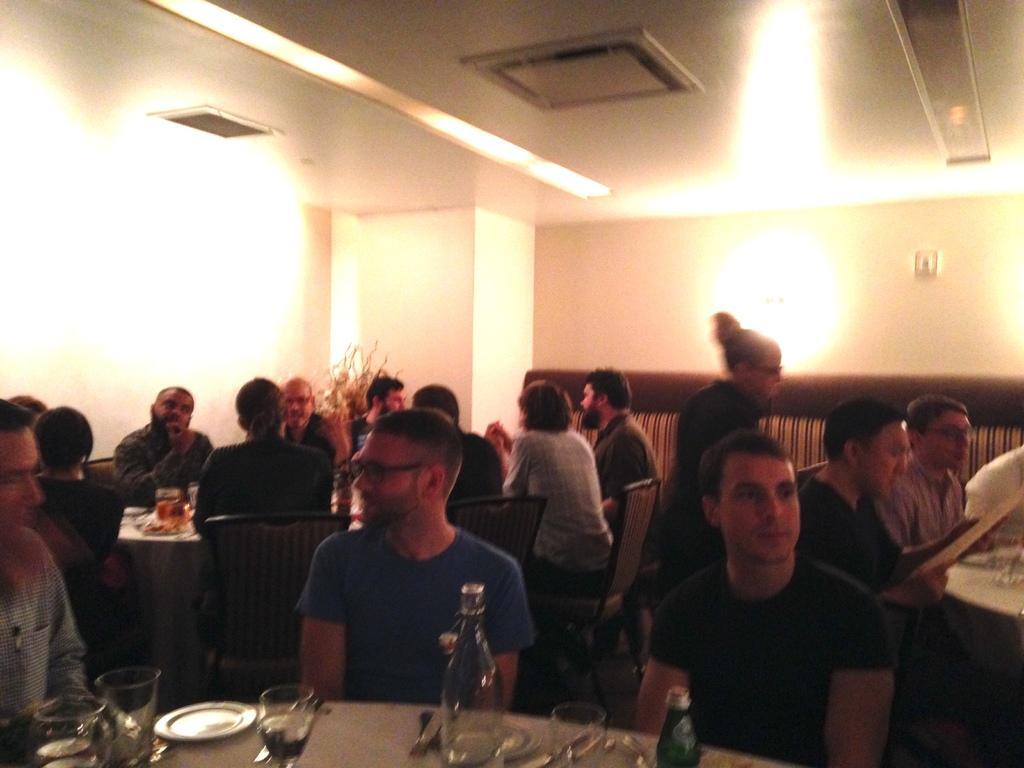How would you summarize this image in a sentence or two? In this picture, we can see a dining room. So many peoples are sat on the cream color chairs. The bottom of the image, we can see dining table. On top of it, glass, bottle, plate we can see. The background, we can see white color wall. At roof, we can see lights. 